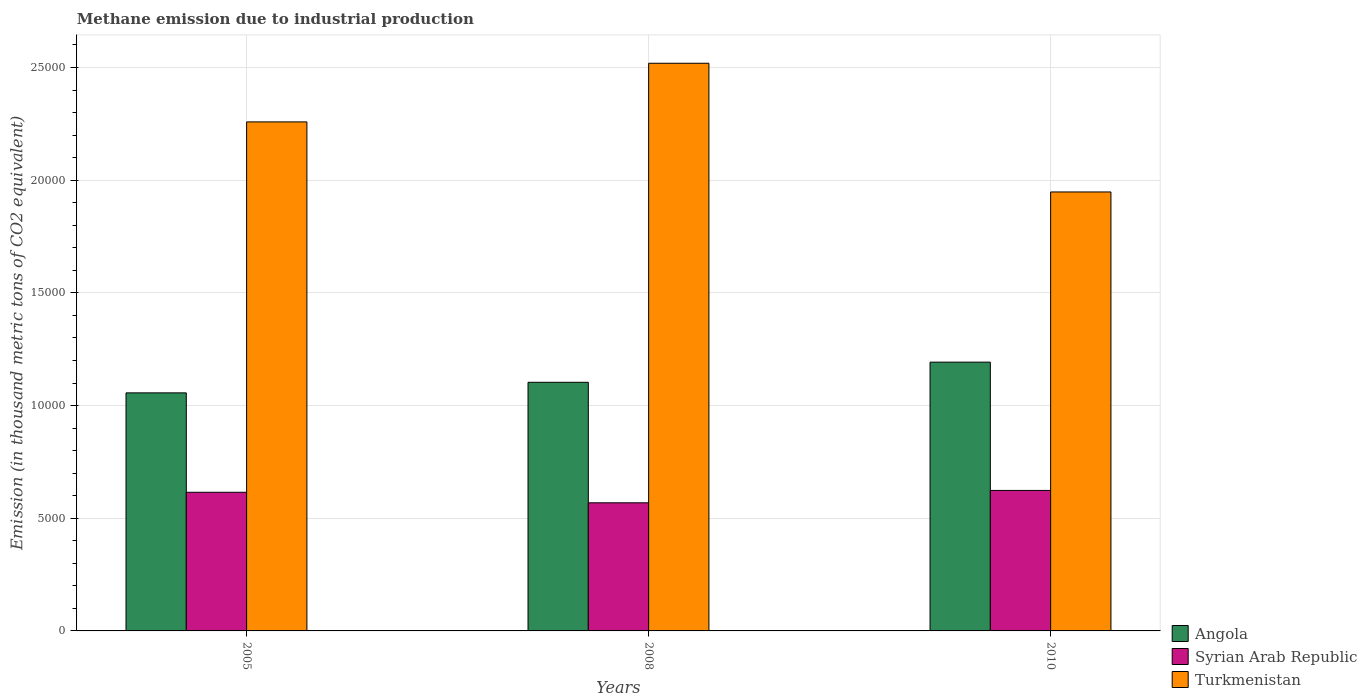How many different coloured bars are there?
Keep it short and to the point. 3. How many groups of bars are there?
Keep it short and to the point. 3. Are the number of bars per tick equal to the number of legend labels?
Provide a short and direct response. Yes. Are the number of bars on each tick of the X-axis equal?
Your answer should be very brief. Yes. How many bars are there on the 3rd tick from the left?
Offer a terse response. 3. What is the amount of methane emitted in Syrian Arab Republic in 2008?
Ensure brevity in your answer.  5684.5. Across all years, what is the maximum amount of methane emitted in Angola?
Keep it short and to the point. 1.19e+04. Across all years, what is the minimum amount of methane emitted in Turkmenistan?
Provide a short and direct response. 1.95e+04. In which year was the amount of methane emitted in Angola minimum?
Offer a terse response. 2005. What is the total amount of methane emitted in Turkmenistan in the graph?
Provide a short and direct response. 6.73e+04. What is the difference between the amount of methane emitted in Syrian Arab Republic in 2005 and that in 2010?
Give a very brief answer. -81.9. What is the difference between the amount of methane emitted in Syrian Arab Republic in 2010 and the amount of methane emitted in Turkmenistan in 2005?
Offer a terse response. -1.64e+04. What is the average amount of methane emitted in Angola per year?
Provide a succinct answer. 1.12e+04. In the year 2008, what is the difference between the amount of methane emitted in Angola and amount of methane emitted in Turkmenistan?
Give a very brief answer. -1.42e+04. In how many years, is the amount of methane emitted in Turkmenistan greater than 12000 thousand metric tons?
Provide a succinct answer. 3. What is the ratio of the amount of methane emitted in Turkmenistan in 2005 to that in 2010?
Your response must be concise. 1.16. Is the amount of methane emitted in Turkmenistan in 2005 less than that in 2010?
Your answer should be compact. No. What is the difference between the highest and the second highest amount of methane emitted in Turkmenistan?
Give a very brief answer. 2602. What is the difference between the highest and the lowest amount of methane emitted in Angola?
Offer a terse response. 1363.6. Is the sum of the amount of methane emitted in Angola in 2005 and 2008 greater than the maximum amount of methane emitted in Turkmenistan across all years?
Offer a terse response. No. What does the 3rd bar from the left in 2005 represents?
Offer a very short reply. Turkmenistan. What does the 3rd bar from the right in 2005 represents?
Provide a short and direct response. Angola. Are all the bars in the graph horizontal?
Provide a succinct answer. No. How many years are there in the graph?
Your response must be concise. 3. What is the difference between two consecutive major ticks on the Y-axis?
Your response must be concise. 5000. Are the values on the major ticks of Y-axis written in scientific E-notation?
Offer a very short reply. No. Does the graph contain grids?
Offer a very short reply. Yes. Where does the legend appear in the graph?
Make the answer very short. Bottom right. How many legend labels are there?
Offer a terse response. 3. How are the legend labels stacked?
Your answer should be compact. Vertical. What is the title of the graph?
Your response must be concise. Methane emission due to industrial production. Does "Gambia, The" appear as one of the legend labels in the graph?
Your answer should be compact. No. What is the label or title of the X-axis?
Make the answer very short. Years. What is the label or title of the Y-axis?
Offer a very short reply. Emission (in thousand metric tons of CO2 equivalent). What is the Emission (in thousand metric tons of CO2 equivalent) of Angola in 2005?
Your answer should be very brief. 1.06e+04. What is the Emission (in thousand metric tons of CO2 equivalent) in Syrian Arab Republic in 2005?
Provide a short and direct response. 6151.7. What is the Emission (in thousand metric tons of CO2 equivalent) of Turkmenistan in 2005?
Make the answer very short. 2.26e+04. What is the Emission (in thousand metric tons of CO2 equivalent) of Angola in 2008?
Your response must be concise. 1.10e+04. What is the Emission (in thousand metric tons of CO2 equivalent) of Syrian Arab Republic in 2008?
Ensure brevity in your answer.  5684.5. What is the Emission (in thousand metric tons of CO2 equivalent) in Turkmenistan in 2008?
Ensure brevity in your answer.  2.52e+04. What is the Emission (in thousand metric tons of CO2 equivalent) in Angola in 2010?
Your answer should be very brief. 1.19e+04. What is the Emission (in thousand metric tons of CO2 equivalent) of Syrian Arab Republic in 2010?
Your response must be concise. 6233.6. What is the Emission (in thousand metric tons of CO2 equivalent) of Turkmenistan in 2010?
Provide a succinct answer. 1.95e+04. Across all years, what is the maximum Emission (in thousand metric tons of CO2 equivalent) of Angola?
Keep it short and to the point. 1.19e+04. Across all years, what is the maximum Emission (in thousand metric tons of CO2 equivalent) of Syrian Arab Republic?
Your response must be concise. 6233.6. Across all years, what is the maximum Emission (in thousand metric tons of CO2 equivalent) of Turkmenistan?
Ensure brevity in your answer.  2.52e+04. Across all years, what is the minimum Emission (in thousand metric tons of CO2 equivalent) of Angola?
Ensure brevity in your answer.  1.06e+04. Across all years, what is the minimum Emission (in thousand metric tons of CO2 equivalent) in Syrian Arab Republic?
Keep it short and to the point. 5684.5. Across all years, what is the minimum Emission (in thousand metric tons of CO2 equivalent) in Turkmenistan?
Give a very brief answer. 1.95e+04. What is the total Emission (in thousand metric tons of CO2 equivalent) in Angola in the graph?
Provide a succinct answer. 3.35e+04. What is the total Emission (in thousand metric tons of CO2 equivalent) in Syrian Arab Republic in the graph?
Offer a terse response. 1.81e+04. What is the total Emission (in thousand metric tons of CO2 equivalent) of Turkmenistan in the graph?
Ensure brevity in your answer.  6.73e+04. What is the difference between the Emission (in thousand metric tons of CO2 equivalent) in Angola in 2005 and that in 2008?
Your answer should be compact. -469.5. What is the difference between the Emission (in thousand metric tons of CO2 equivalent) of Syrian Arab Republic in 2005 and that in 2008?
Offer a terse response. 467.2. What is the difference between the Emission (in thousand metric tons of CO2 equivalent) in Turkmenistan in 2005 and that in 2008?
Provide a succinct answer. -2602. What is the difference between the Emission (in thousand metric tons of CO2 equivalent) in Angola in 2005 and that in 2010?
Keep it short and to the point. -1363.6. What is the difference between the Emission (in thousand metric tons of CO2 equivalent) in Syrian Arab Republic in 2005 and that in 2010?
Offer a very short reply. -81.9. What is the difference between the Emission (in thousand metric tons of CO2 equivalent) of Turkmenistan in 2005 and that in 2010?
Your answer should be very brief. 3108.7. What is the difference between the Emission (in thousand metric tons of CO2 equivalent) of Angola in 2008 and that in 2010?
Provide a short and direct response. -894.1. What is the difference between the Emission (in thousand metric tons of CO2 equivalent) of Syrian Arab Republic in 2008 and that in 2010?
Offer a terse response. -549.1. What is the difference between the Emission (in thousand metric tons of CO2 equivalent) of Turkmenistan in 2008 and that in 2010?
Ensure brevity in your answer.  5710.7. What is the difference between the Emission (in thousand metric tons of CO2 equivalent) in Angola in 2005 and the Emission (in thousand metric tons of CO2 equivalent) in Syrian Arab Republic in 2008?
Offer a terse response. 4877.9. What is the difference between the Emission (in thousand metric tons of CO2 equivalent) in Angola in 2005 and the Emission (in thousand metric tons of CO2 equivalent) in Turkmenistan in 2008?
Offer a terse response. -1.46e+04. What is the difference between the Emission (in thousand metric tons of CO2 equivalent) in Syrian Arab Republic in 2005 and the Emission (in thousand metric tons of CO2 equivalent) in Turkmenistan in 2008?
Your answer should be very brief. -1.90e+04. What is the difference between the Emission (in thousand metric tons of CO2 equivalent) in Angola in 2005 and the Emission (in thousand metric tons of CO2 equivalent) in Syrian Arab Republic in 2010?
Ensure brevity in your answer.  4328.8. What is the difference between the Emission (in thousand metric tons of CO2 equivalent) in Angola in 2005 and the Emission (in thousand metric tons of CO2 equivalent) in Turkmenistan in 2010?
Offer a terse response. -8914.7. What is the difference between the Emission (in thousand metric tons of CO2 equivalent) in Syrian Arab Republic in 2005 and the Emission (in thousand metric tons of CO2 equivalent) in Turkmenistan in 2010?
Offer a very short reply. -1.33e+04. What is the difference between the Emission (in thousand metric tons of CO2 equivalent) of Angola in 2008 and the Emission (in thousand metric tons of CO2 equivalent) of Syrian Arab Republic in 2010?
Your answer should be compact. 4798.3. What is the difference between the Emission (in thousand metric tons of CO2 equivalent) of Angola in 2008 and the Emission (in thousand metric tons of CO2 equivalent) of Turkmenistan in 2010?
Offer a very short reply. -8445.2. What is the difference between the Emission (in thousand metric tons of CO2 equivalent) in Syrian Arab Republic in 2008 and the Emission (in thousand metric tons of CO2 equivalent) in Turkmenistan in 2010?
Your answer should be very brief. -1.38e+04. What is the average Emission (in thousand metric tons of CO2 equivalent) of Angola per year?
Your answer should be compact. 1.12e+04. What is the average Emission (in thousand metric tons of CO2 equivalent) in Syrian Arab Republic per year?
Keep it short and to the point. 6023.27. What is the average Emission (in thousand metric tons of CO2 equivalent) in Turkmenistan per year?
Make the answer very short. 2.24e+04. In the year 2005, what is the difference between the Emission (in thousand metric tons of CO2 equivalent) in Angola and Emission (in thousand metric tons of CO2 equivalent) in Syrian Arab Republic?
Make the answer very short. 4410.7. In the year 2005, what is the difference between the Emission (in thousand metric tons of CO2 equivalent) of Angola and Emission (in thousand metric tons of CO2 equivalent) of Turkmenistan?
Offer a very short reply. -1.20e+04. In the year 2005, what is the difference between the Emission (in thousand metric tons of CO2 equivalent) of Syrian Arab Republic and Emission (in thousand metric tons of CO2 equivalent) of Turkmenistan?
Ensure brevity in your answer.  -1.64e+04. In the year 2008, what is the difference between the Emission (in thousand metric tons of CO2 equivalent) of Angola and Emission (in thousand metric tons of CO2 equivalent) of Syrian Arab Republic?
Your answer should be compact. 5347.4. In the year 2008, what is the difference between the Emission (in thousand metric tons of CO2 equivalent) in Angola and Emission (in thousand metric tons of CO2 equivalent) in Turkmenistan?
Provide a succinct answer. -1.42e+04. In the year 2008, what is the difference between the Emission (in thousand metric tons of CO2 equivalent) of Syrian Arab Republic and Emission (in thousand metric tons of CO2 equivalent) of Turkmenistan?
Provide a succinct answer. -1.95e+04. In the year 2010, what is the difference between the Emission (in thousand metric tons of CO2 equivalent) in Angola and Emission (in thousand metric tons of CO2 equivalent) in Syrian Arab Republic?
Provide a succinct answer. 5692.4. In the year 2010, what is the difference between the Emission (in thousand metric tons of CO2 equivalent) in Angola and Emission (in thousand metric tons of CO2 equivalent) in Turkmenistan?
Keep it short and to the point. -7551.1. In the year 2010, what is the difference between the Emission (in thousand metric tons of CO2 equivalent) in Syrian Arab Republic and Emission (in thousand metric tons of CO2 equivalent) in Turkmenistan?
Offer a terse response. -1.32e+04. What is the ratio of the Emission (in thousand metric tons of CO2 equivalent) in Angola in 2005 to that in 2008?
Make the answer very short. 0.96. What is the ratio of the Emission (in thousand metric tons of CO2 equivalent) of Syrian Arab Republic in 2005 to that in 2008?
Ensure brevity in your answer.  1.08. What is the ratio of the Emission (in thousand metric tons of CO2 equivalent) in Turkmenistan in 2005 to that in 2008?
Give a very brief answer. 0.9. What is the ratio of the Emission (in thousand metric tons of CO2 equivalent) of Angola in 2005 to that in 2010?
Give a very brief answer. 0.89. What is the ratio of the Emission (in thousand metric tons of CO2 equivalent) of Syrian Arab Republic in 2005 to that in 2010?
Offer a very short reply. 0.99. What is the ratio of the Emission (in thousand metric tons of CO2 equivalent) in Turkmenistan in 2005 to that in 2010?
Your response must be concise. 1.16. What is the ratio of the Emission (in thousand metric tons of CO2 equivalent) in Angola in 2008 to that in 2010?
Ensure brevity in your answer.  0.93. What is the ratio of the Emission (in thousand metric tons of CO2 equivalent) of Syrian Arab Republic in 2008 to that in 2010?
Provide a succinct answer. 0.91. What is the ratio of the Emission (in thousand metric tons of CO2 equivalent) in Turkmenistan in 2008 to that in 2010?
Your answer should be compact. 1.29. What is the difference between the highest and the second highest Emission (in thousand metric tons of CO2 equivalent) in Angola?
Offer a very short reply. 894.1. What is the difference between the highest and the second highest Emission (in thousand metric tons of CO2 equivalent) of Syrian Arab Republic?
Keep it short and to the point. 81.9. What is the difference between the highest and the second highest Emission (in thousand metric tons of CO2 equivalent) in Turkmenistan?
Give a very brief answer. 2602. What is the difference between the highest and the lowest Emission (in thousand metric tons of CO2 equivalent) of Angola?
Keep it short and to the point. 1363.6. What is the difference between the highest and the lowest Emission (in thousand metric tons of CO2 equivalent) in Syrian Arab Republic?
Offer a very short reply. 549.1. What is the difference between the highest and the lowest Emission (in thousand metric tons of CO2 equivalent) of Turkmenistan?
Your answer should be very brief. 5710.7. 